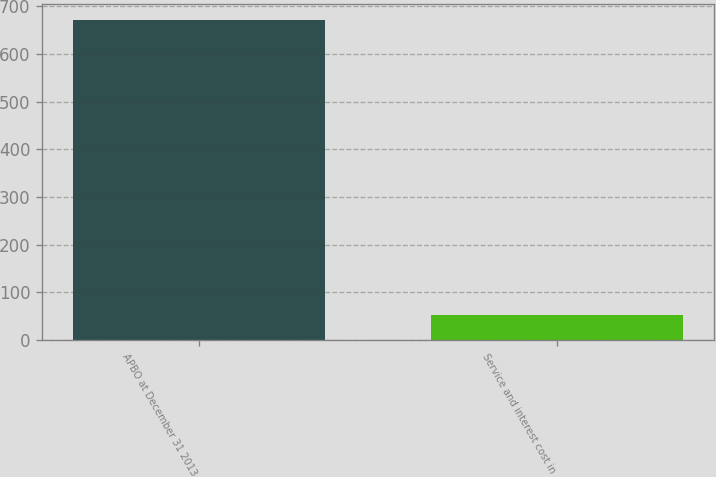<chart> <loc_0><loc_0><loc_500><loc_500><bar_chart><fcel>APBO at December 31 2013<fcel>Service and interest cost in<nl><fcel>671<fcel>52<nl></chart> 